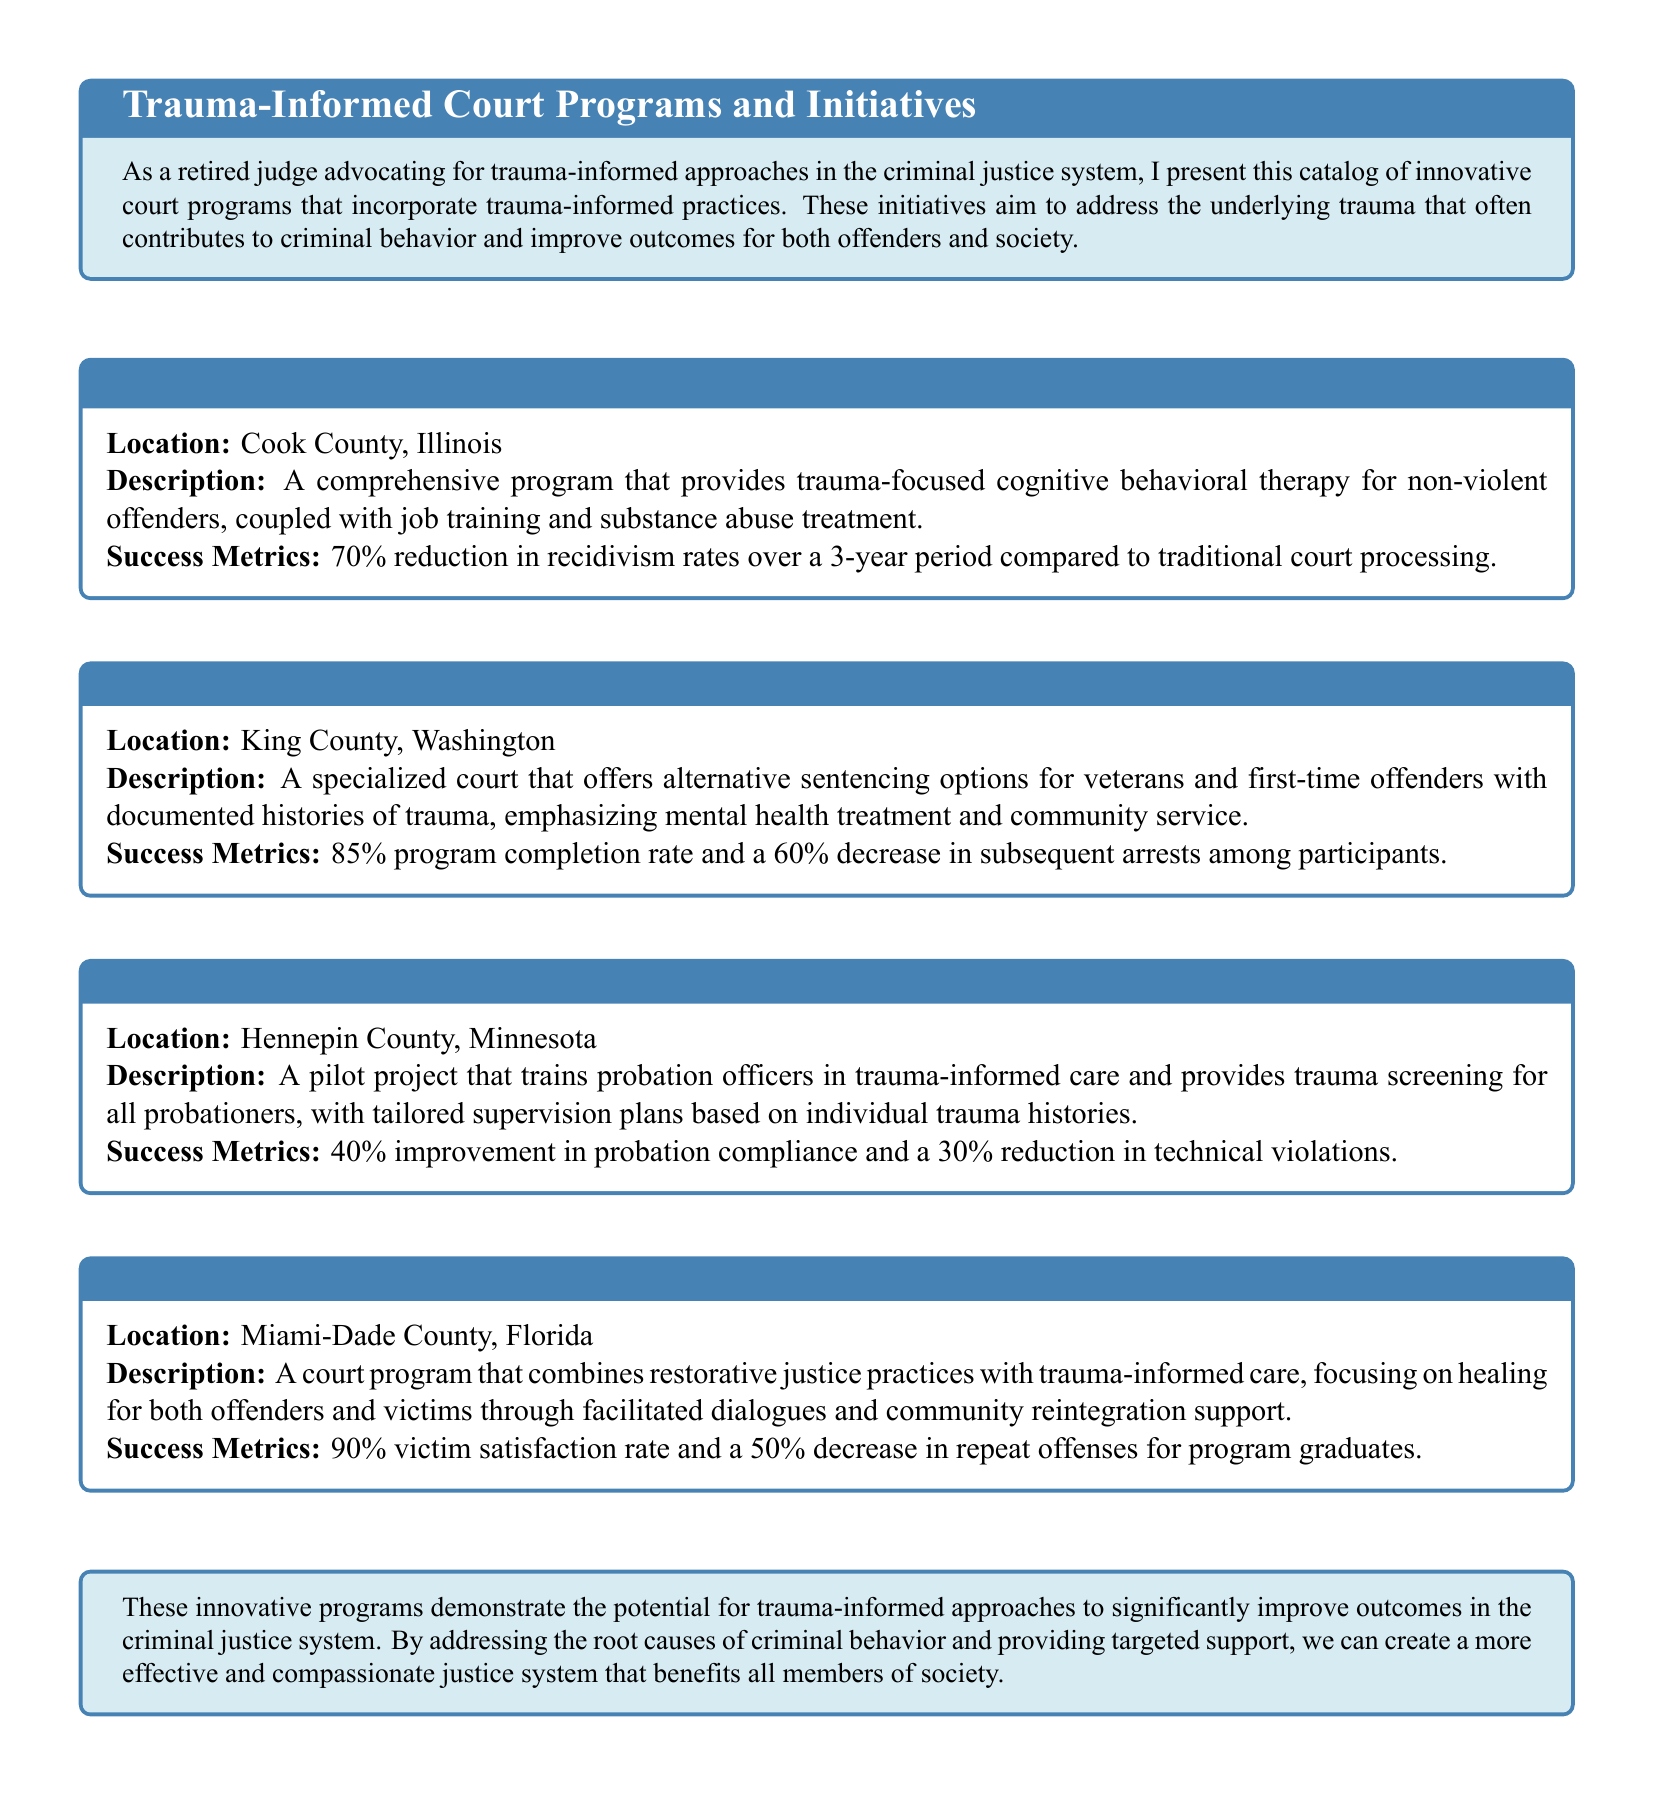What is the location of Project STRONG? The location of Project STRONG is mentioned in the document as Cook County, Illinois.
Answer: Cook County, Illinois What is the primary focus of the HEAL Court? The primary focus of the HEAL Court is alternative sentencing options for veterans and first-time offenders with documented histories of trauma, emphasizing mental health treatment and community service.
Answer: Mental health treatment and community service What percentage reduction in recidivism does Project STRONG achieve? The document states that Project STRONG achieves a 70% reduction in recidivism rates over a 3-year period compared to traditional court processing.
Answer: 70% What unique approach does the Trauma-Informed Probation Initiative utilize? The Trauma-Informed Probation Initiative utilizes trauma-informed care for training probation officers and provides trauma screening for all probationers.
Answer: Trauma-informed care What is the victim satisfaction rate for the Restorative Trauma Court? The document indicates that the Restorative Trauma Court has a 90% victim satisfaction rate.
Answer: 90% Which program shows a 50% decrease in repeat offenses? The program that shows a 50% decrease in repeat offenses is the Restorative Trauma Court as noted in the document.
Answer: Restorative Trauma Court What city is home to the HEAL Court? The HEAL Court is located in King County, Washington, as mentioned in the document.
Answer: King County, Washington How much improvement in probation compliance does the Trauma-Informed Probation Initiative report? The document reports a 40% improvement in probation compliance for the Trauma-Informed Probation Initiative.
Answer: 40% 